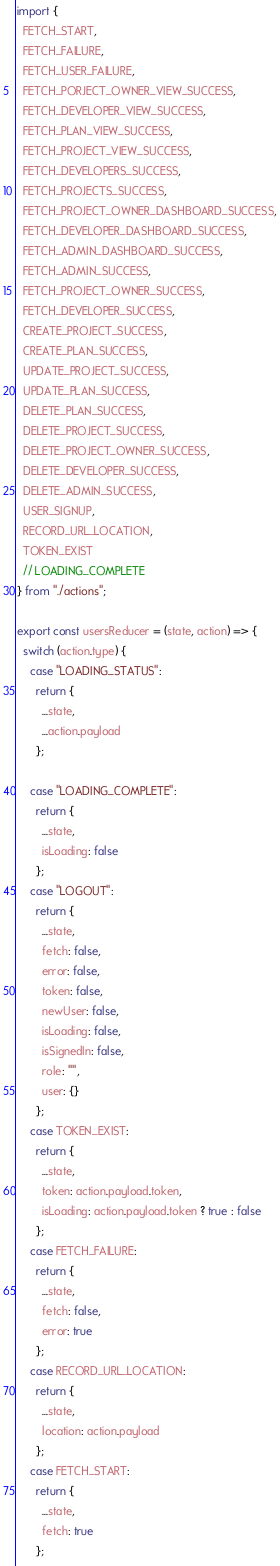<code> <loc_0><loc_0><loc_500><loc_500><_JavaScript_>import {
  FETCH_START,
  FETCH_FAILURE,
  FETCH_USER_FAILURE,
  FETCH_PORJECT_OWNER_VIEW_SUCCESS,
  FETCH_DEVELOPER_VIEW_SUCCESS,
  FETCH_PLAN_VIEW_SUCCESS,
  FETCH_PROJECT_VIEW_SUCCESS,
  FETCH_DEVELOPERS_SUCCESS,
  FETCH_PROJECTS_SUCCESS,
  FETCH_PROJECT_OWNER_DASHBOARD_SUCCESS,
  FETCH_DEVELOPER_DASHBOARD_SUCCESS,
  FETCH_ADMIN_DASHBOARD_SUCCESS,
  FETCH_ADMIN_SUCCESS,
  FETCH_PROJECT_OWNER_SUCCESS,
  FETCH_DEVELOPER_SUCCESS,
  CREATE_PROJECT_SUCCESS,
  CREATE_PLAN_SUCCESS,
  UPDATE_PROJECT_SUCCESS,
  UPDATE_PLAN_SUCCESS,
  DELETE_PLAN_SUCCESS,
  DELETE_PROJECT_SUCCESS,
  DELETE_PROJECT_OWNER_SUCCESS,
  DELETE_DEVELOPER_SUCCESS,
  DELETE_ADMIN_SUCCESS,
  USER_SIGNUP,
  RECORD_URL_LOCATION,
  TOKEN_EXIST
  // LOADING_COMPLETE
} from "./actions";

export const usersReducer = (state, action) => {
  switch (action.type) {
    case "LOADING_STATUS":
      return {
        ...state,
        ...action.payload
      };

    case "LOADING_COMPLETE":
      return {
        ...state,
        isLoading: false
      };
    case "LOGOUT":
      return {
        ...state,
        fetch: false,
        error: false,
        token: false,
        newUser: false,
        isLoading: false,
        isSignedIn: false,
        role: "",
        user: {}
      };
    case TOKEN_EXIST:
      return {
        ...state,
        token: action.payload.token,
        isLoading: action.payload.token ? true : false
      };
    case FETCH_FAILURE:
      return {
        ...state,
        fetch: false,
        error: true
      };
    case RECORD_URL_LOCATION:
      return {
        ...state,
        location: action.payload
      };
    case FETCH_START:
      return {
        ...state,
        fetch: true
      };</code> 